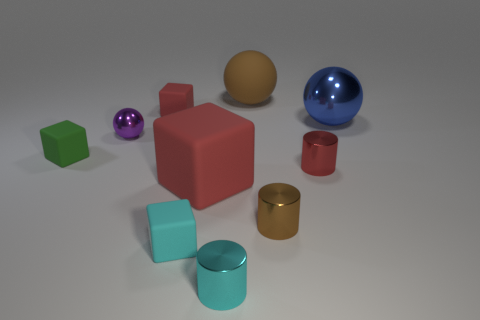Subtract all brown blocks. Subtract all green cylinders. How many blocks are left? 4 Subtract all cylinders. How many objects are left? 7 Subtract 1 brown cylinders. How many objects are left? 9 Subtract all rubber cylinders. Subtract all big rubber objects. How many objects are left? 8 Add 1 red rubber things. How many red rubber things are left? 3 Add 1 small rubber objects. How many small rubber objects exist? 4 